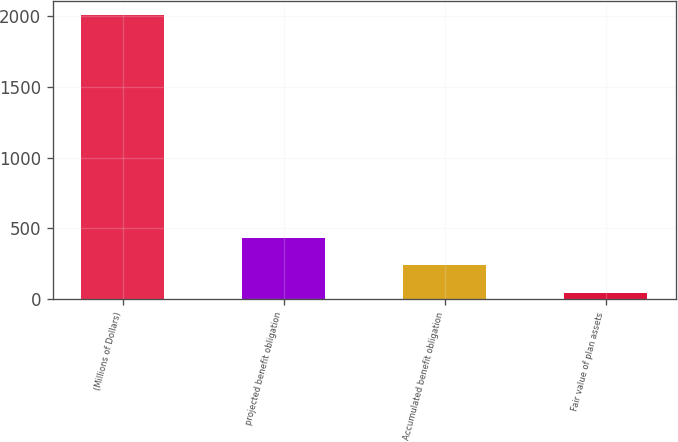<chart> <loc_0><loc_0><loc_500><loc_500><bar_chart><fcel>(Millions of Dollars)<fcel>projected benefit obligation<fcel>Accumulated benefit obligation<fcel>Fair value of plan assets<nl><fcel>2005<fcel>434.28<fcel>237.94<fcel>41.6<nl></chart> 